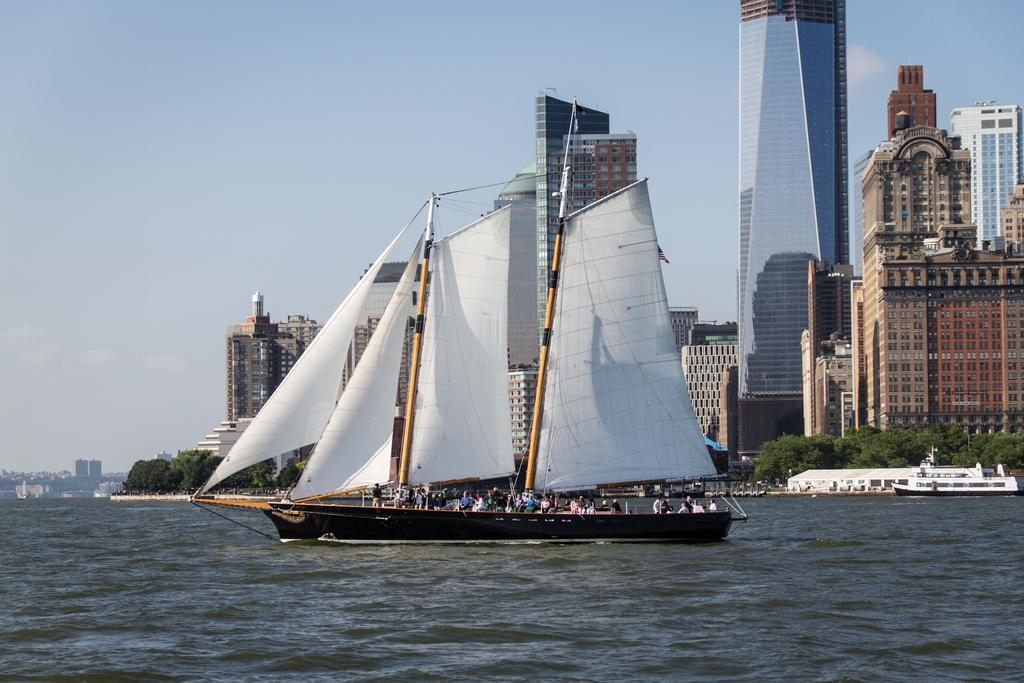What is happening to the boats in the image? The boats are above the water in the image. What can be seen in the background of the image? There are buildings and trees in the background of the image. Are there any people in the boats? Yes, there are people in the boats. What features can be observed on the buildings? The buildings have windows. What is the color of the sky in the image? The sky is blue in the image. Can you tell me where the zoo is located in the image? There is no zoo present in the image. What type of glove is being used by the people in the boats? There is no glove visible in the image; the people in the boats do not appear to be wearing any gloves. 